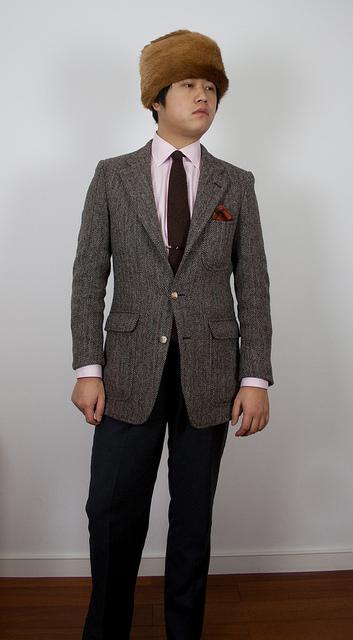What color is the guys trousers?
Be succinct. Black. How many buttons are closed?
Write a very short answer. 1. Are his arms by his side?
Give a very brief answer. Yes. Is the man tall?
Keep it brief. No. What color is his shirt?
Answer briefly. Pink. What material is the hat made of?
Short answer required. Fur. Which button is undone?
Give a very brief answer. Bottom. Does this guy think he's cool?
Give a very brief answer. Yes. What is around the man's neck?
Answer briefly. Tie. 